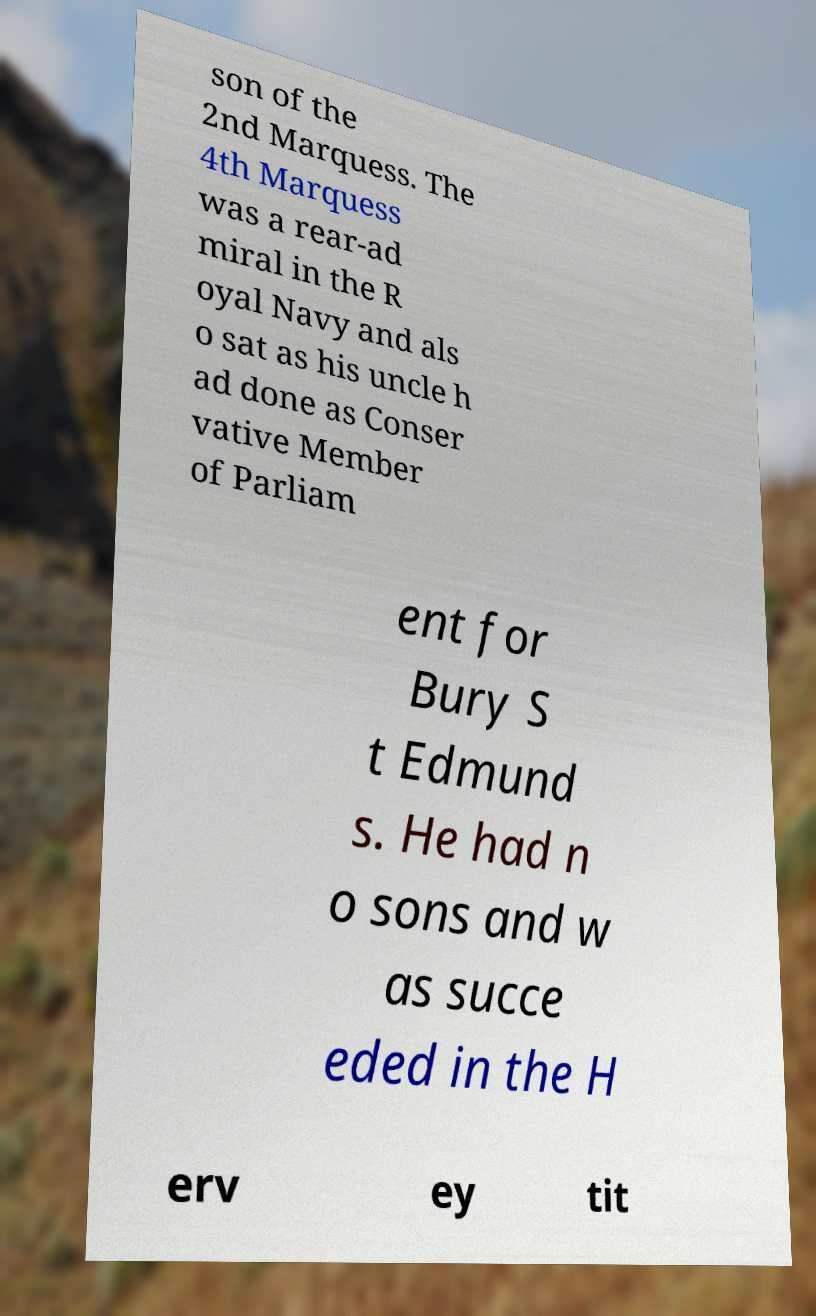Can you read and provide the text displayed in the image?This photo seems to have some interesting text. Can you extract and type it out for me? son of the 2nd Marquess. The 4th Marquess was a rear-ad miral in the R oyal Navy and als o sat as his uncle h ad done as Conser vative Member of Parliam ent for Bury S t Edmund s. He had n o sons and w as succe eded in the H erv ey tit 